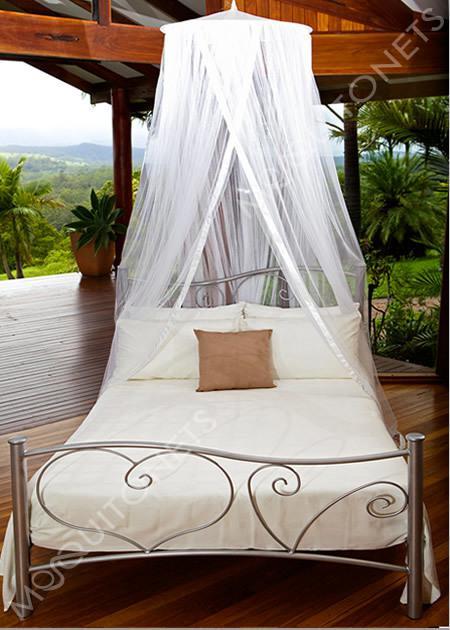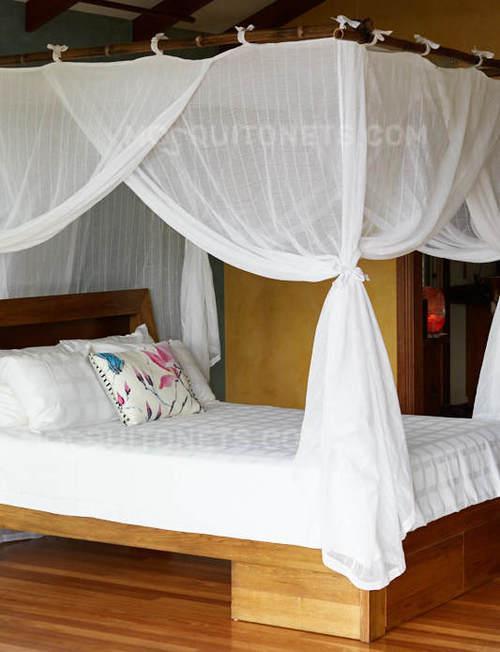The first image is the image on the left, the second image is the image on the right. For the images shown, is this caption "The right image shows a dome-shaped bed enclosure." true? Answer yes or no. No. 